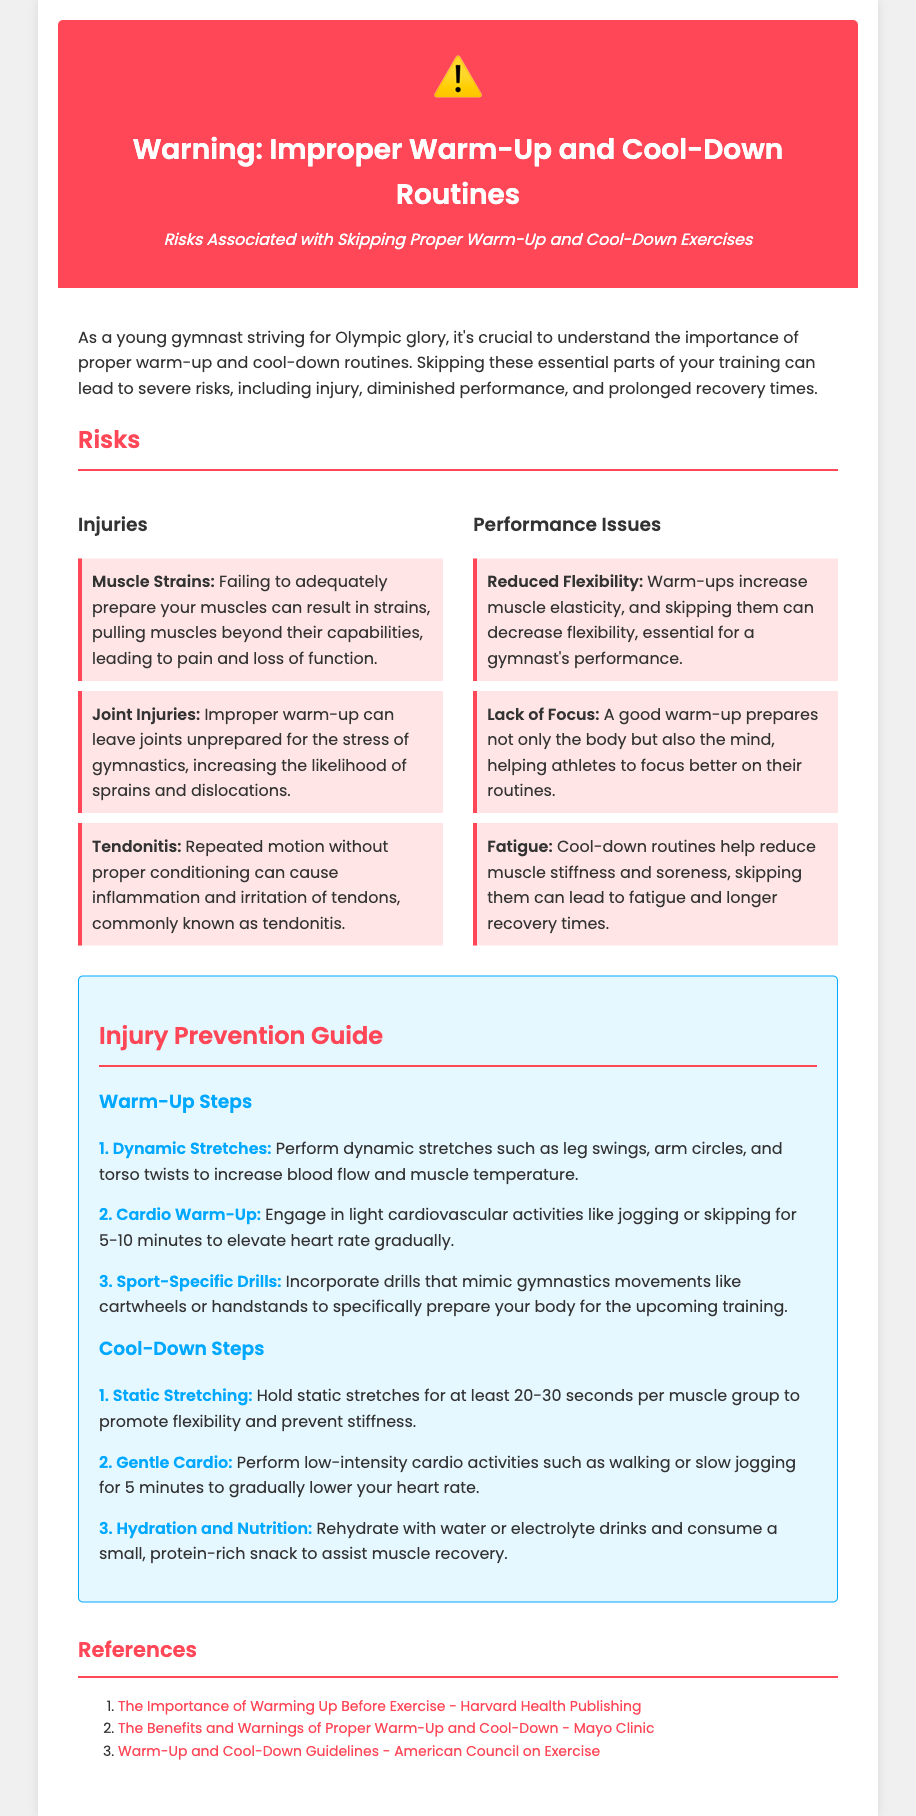What is the title of the document? The title of the document is located in the header section and clearly states the purpose of the warning.
Answer: Warning: Improper Warm-Up and Cool-Down Routines What symbol is used to represent a warning in the document? The warning icon is a prominent element that visually emphasizes the document's caution message.
Answer: ⚠️ How many steps are listed for the warm-up guide? The warm-up guide contains a specific number of steps detailed for injury prevention through proper warm-up techniques.
Answer: 3 What type of stretching is recommended for cool-down? The document specifically distinguishes the type of stretching to be performed, providing guidance for proper recovery.
Answer: Static Stretching Which injury is associated with skipping proper warm-up and cool-down? The document mentions various injuries, emphasizing the potential consequences of neglecting warm-up and cool-down practices.
Answer: Muscle Strains What does skipping warm-ups affect negatively that is crucial for performance? The risks section elaborates on specific performance issues resulting from skipping warm-ups, indicating a direct correlation with flexibility.
Answer: Reduced Flexibility How long should static stretches be held during a cool-down? The cool-down steps give precise instructions on how to perform static stretches, including time duration to achieve effectiveness.
Answer: 20-30 seconds What is the first step in the warm-up guide? The detailed warm-up guide presents a clear sequence of steps, starting with the initial action to take before engaging in gymnastics training.
Answer: Dynamic Stretches What should be consumed after exercise according to the cool-down steps? The cool-down section emphasizes the importance of hydration and nutrition, specifying what to consume for optimal recovery.
Answer: Protein-rich snack 